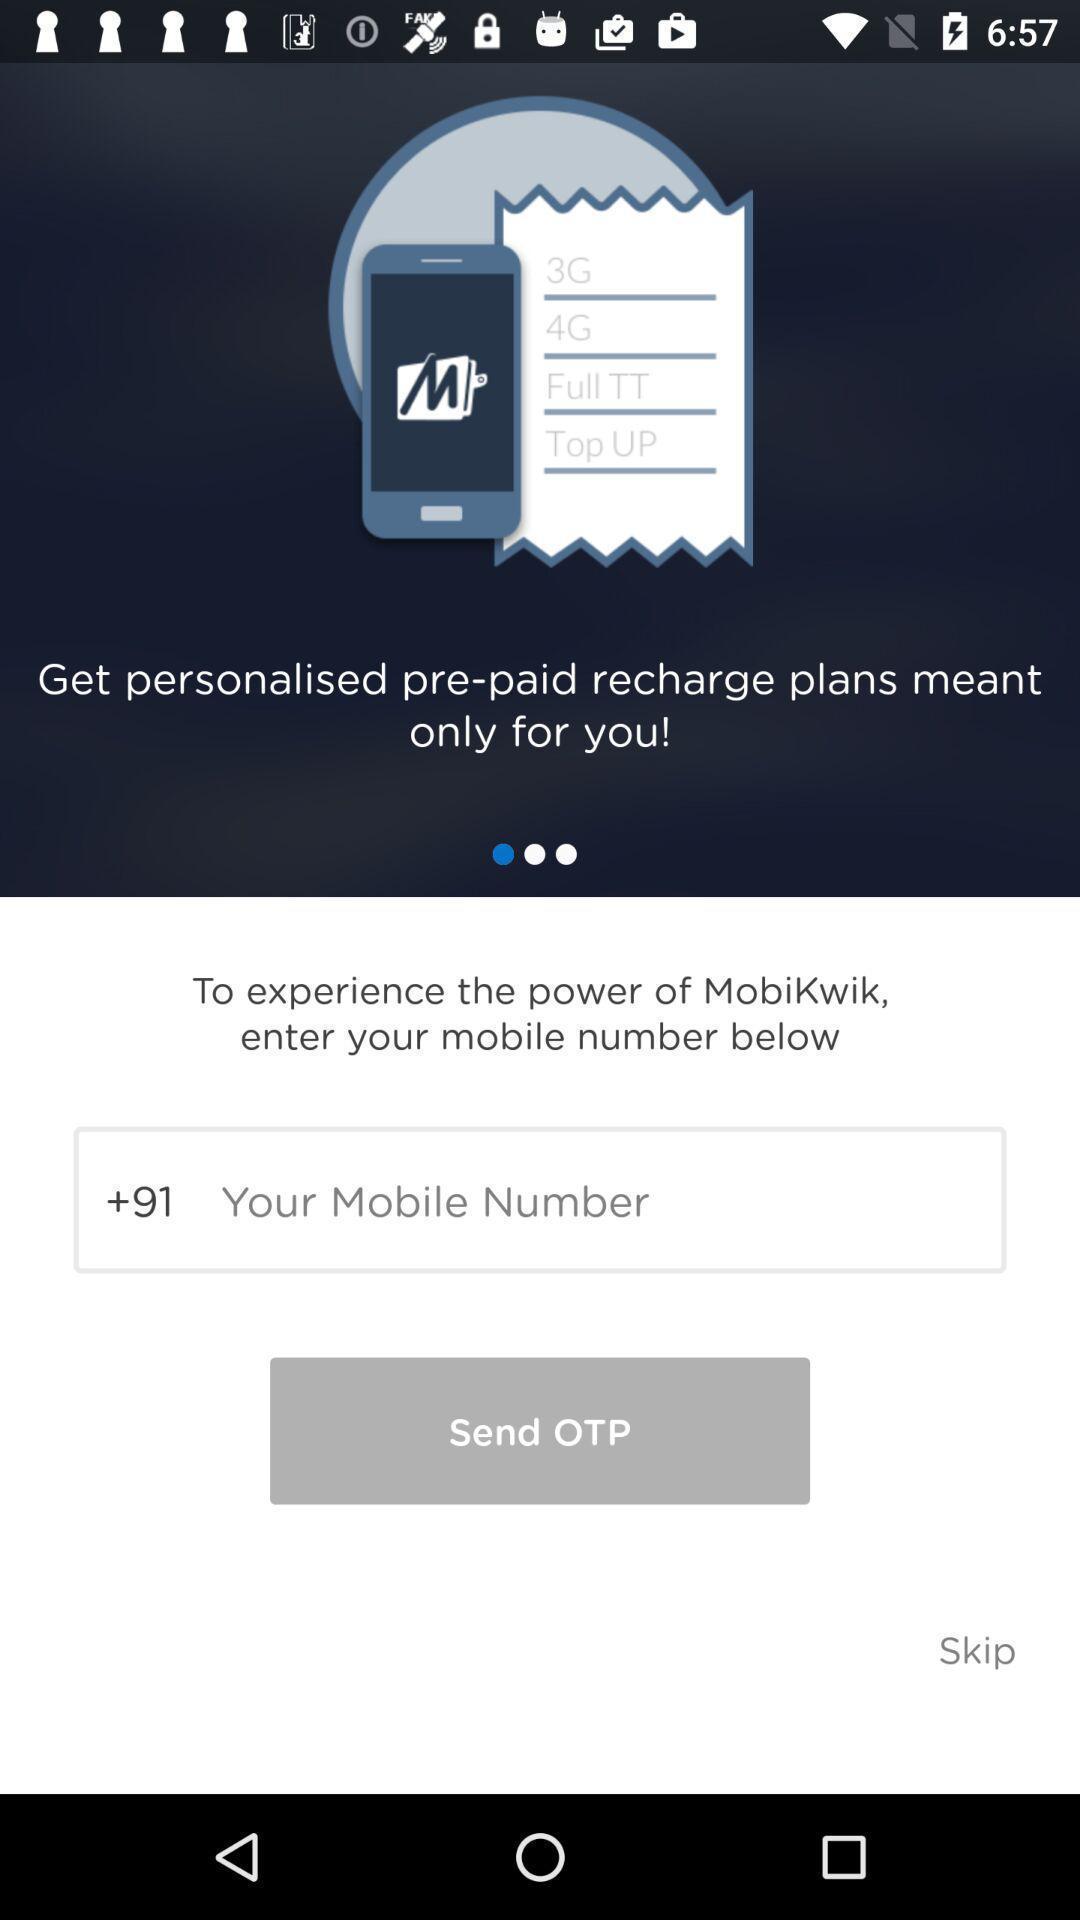Tell me what you see in this picture. Welcome page for a banking app. 